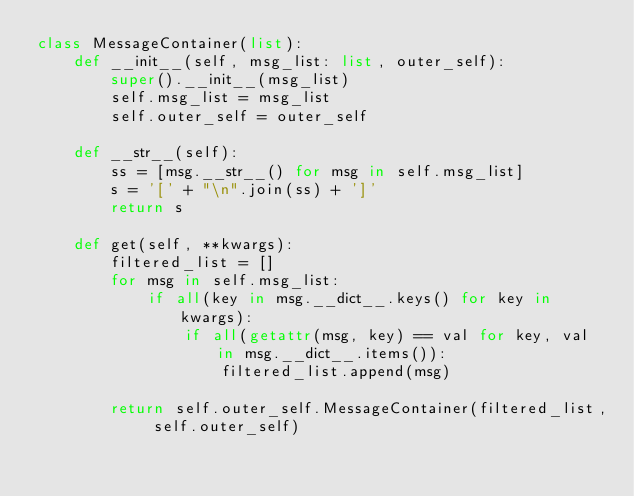Convert code to text. <code><loc_0><loc_0><loc_500><loc_500><_Python_>class MessageContainer(list):
    def __init__(self, msg_list: list, outer_self):
        super().__init__(msg_list)
        self.msg_list = msg_list
        self.outer_self = outer_self

    def __str__(self):
        ss = [msg.__str__() for msg in self.msg_list]
        s = '[' + "\n".join(ss) + ']'
        return s

    def get(self, **kwargs):
        filtered_list = []
        for msg in self.msg_list:
            if all(key in msg.__dict__.keys() for key in kwargs):
                if all(getattr(msg, key) == val for key, val in msg.__dict__.items()):
                    filtered_list.append(msg)

        return self.outer_self.MessageContainer(filtered_list, self.outer_self)
</code> 